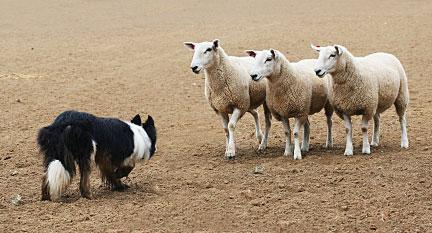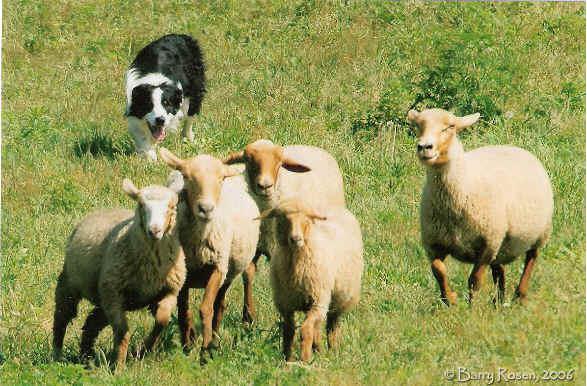The first image is the image on the left, the second image is the image on the right. Considering the images on both sides, is "Some of the animals are near a wooden fence." valid? Answer yes or no. No. The first image is the image on the left, the second image is the image on the right. For the images shown, is this caption "The right photo contains exactly three sheep." true? Answer yes or no. No. 